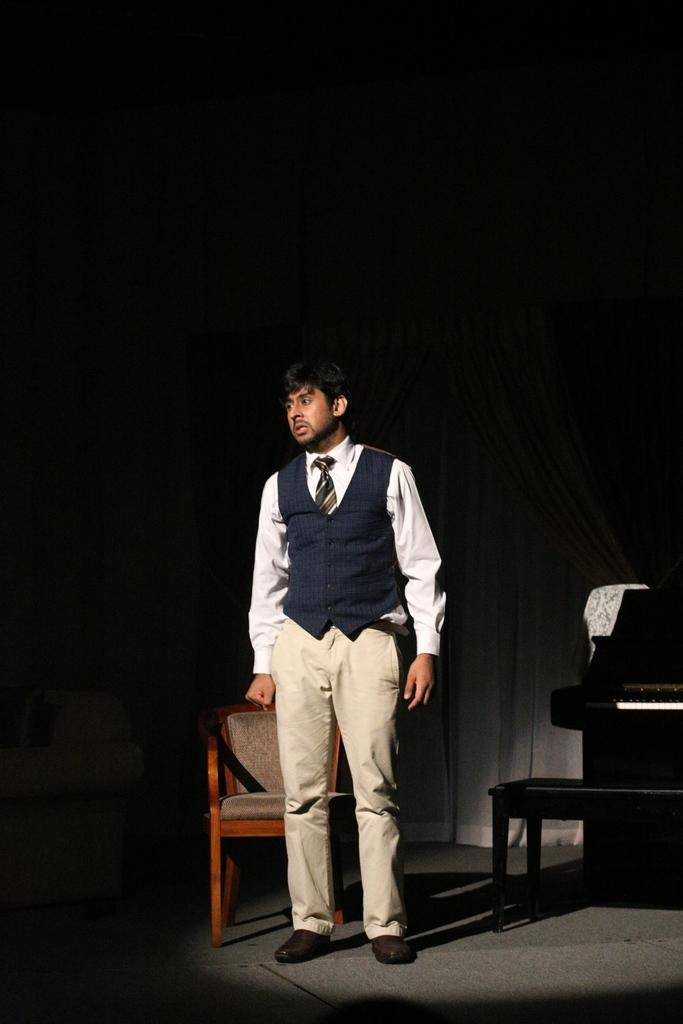What is the main subject in the image? There is a man standing in the image. What object can be seen near the man? There is a chair in the image. What other item is present in the image? There is a piano in the image. How many balls are visible in the image? There are no balls present in the image. What type of wrench is being used by the man in the image? There is no wrench present in the image, and the man is not using any tools. 